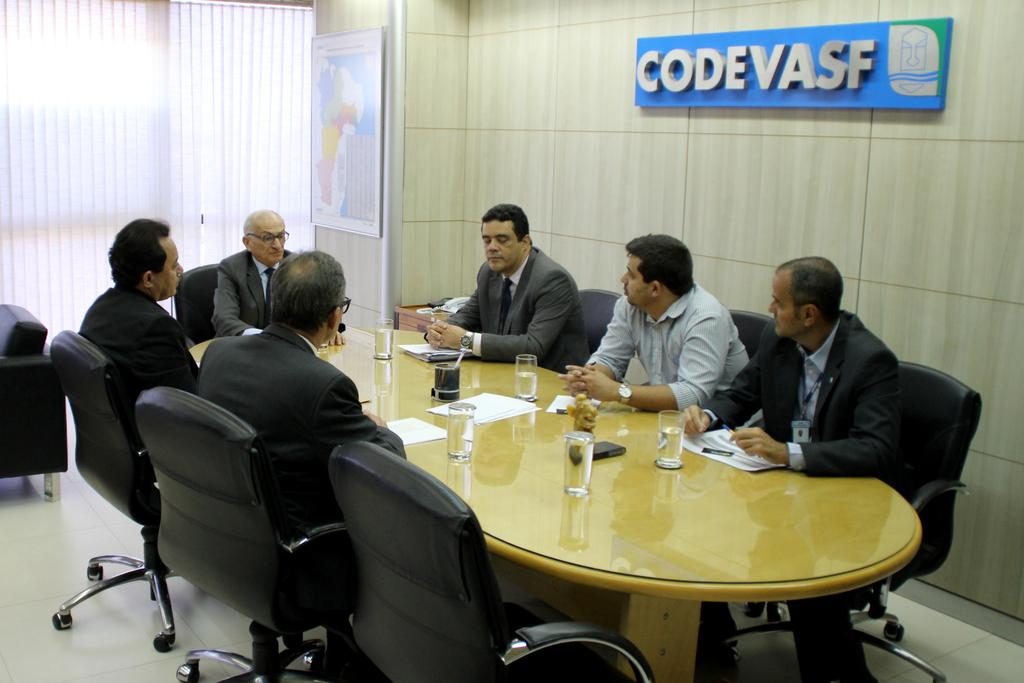<image>
Give a short and clear explanation of the subsequent image. A group of men sitting around the table with a sign that says "CodeVasf" above there heats 